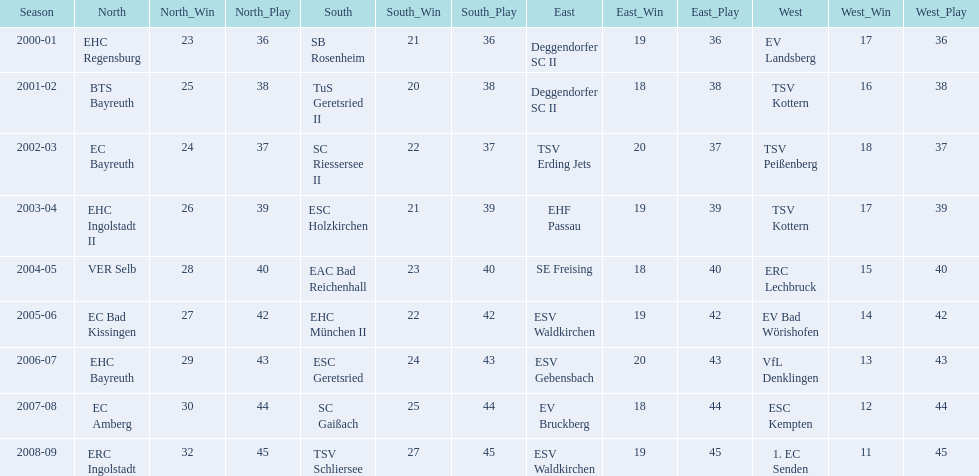Which teams won the north in their respective years? 2000-01, EHC Regensburg, BTS Bayreuth, EC Bayreuth, EHC Ingolstadt II, VER Selb, EC Bad Kissingen, EHC Bayreuth, EC Amberg, ERC Ingolstadt. Which one only won in 2000-01? EHC Regensburg. 